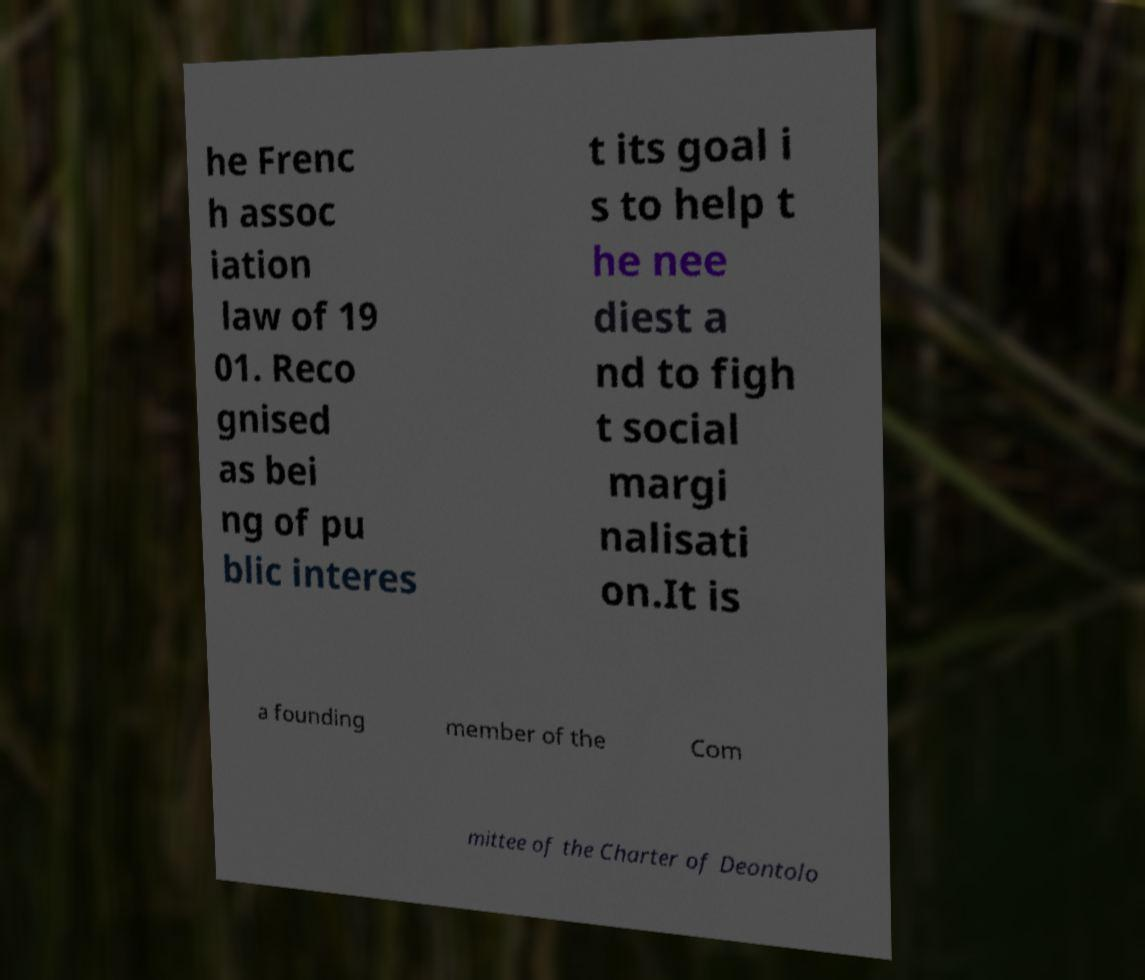What messages or text are displayed in this image? I need them in a readable, typed format. he Frenc h assoc iation law of 19 01. Reco gnised as bei ng of pu blic interes t its goal i s to help t he nee diest a nd to figh t social margi nalisati on.It is a founding member of the Com mittee of the Charter of Deontolo 